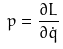<formula> <loc_0><loc_0><loc_500><loc_500>p = \frac { \partial L } { \partial \dot { q } }</formula> 